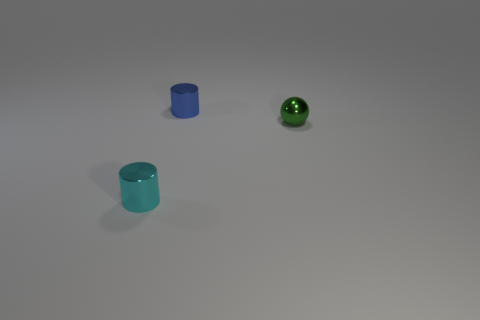How many things are small cyan shiny objects that are in front of the green object or small shiny cylinders in front of the blue cylinder?
Give a very brief answer. 1. Does the small cylinder that is on the left side of the blue cylinder have the same material as the tiny cylinder that is behind the small sphere?
Your response must be concise. Yes. There is a tiny blue shiny object on the right side of the tiny metal object to the left of the blue shiny cylinder; what is its shape?
Give a very brief answer. Cylinder. Is there any other thing that has the same color as the shiny ball?
Offer a terse response. No. Is there a small blue shiny cylinder that is left of the tiny metallic cylinder that is right of the small metallic cylinder left of the blue metallic cylinder?
Make the answer very short. No. Is the color of the small cylinder that is in front of the green metallic sphere the same as the object right of the small blue metal cylinder?
Give a very brief answer. No. There is a blue object that is the same size as the cyan metallic cylinder; what is its material?
Ensure brevity in your answer.  Metal. There is a cylinder that is to the right of the tiny metallic cylinder in front of the tiny shiny thing that is behind the small green shiny ball; how big is it?
Your answer should be very brief. Small. What number of other things are the same material as the small cyan thing?
Ensure brevity in your answer.  2. What size is the metal cylinder behind the tiny green metal object?
Keep it short and to the point. Small. 